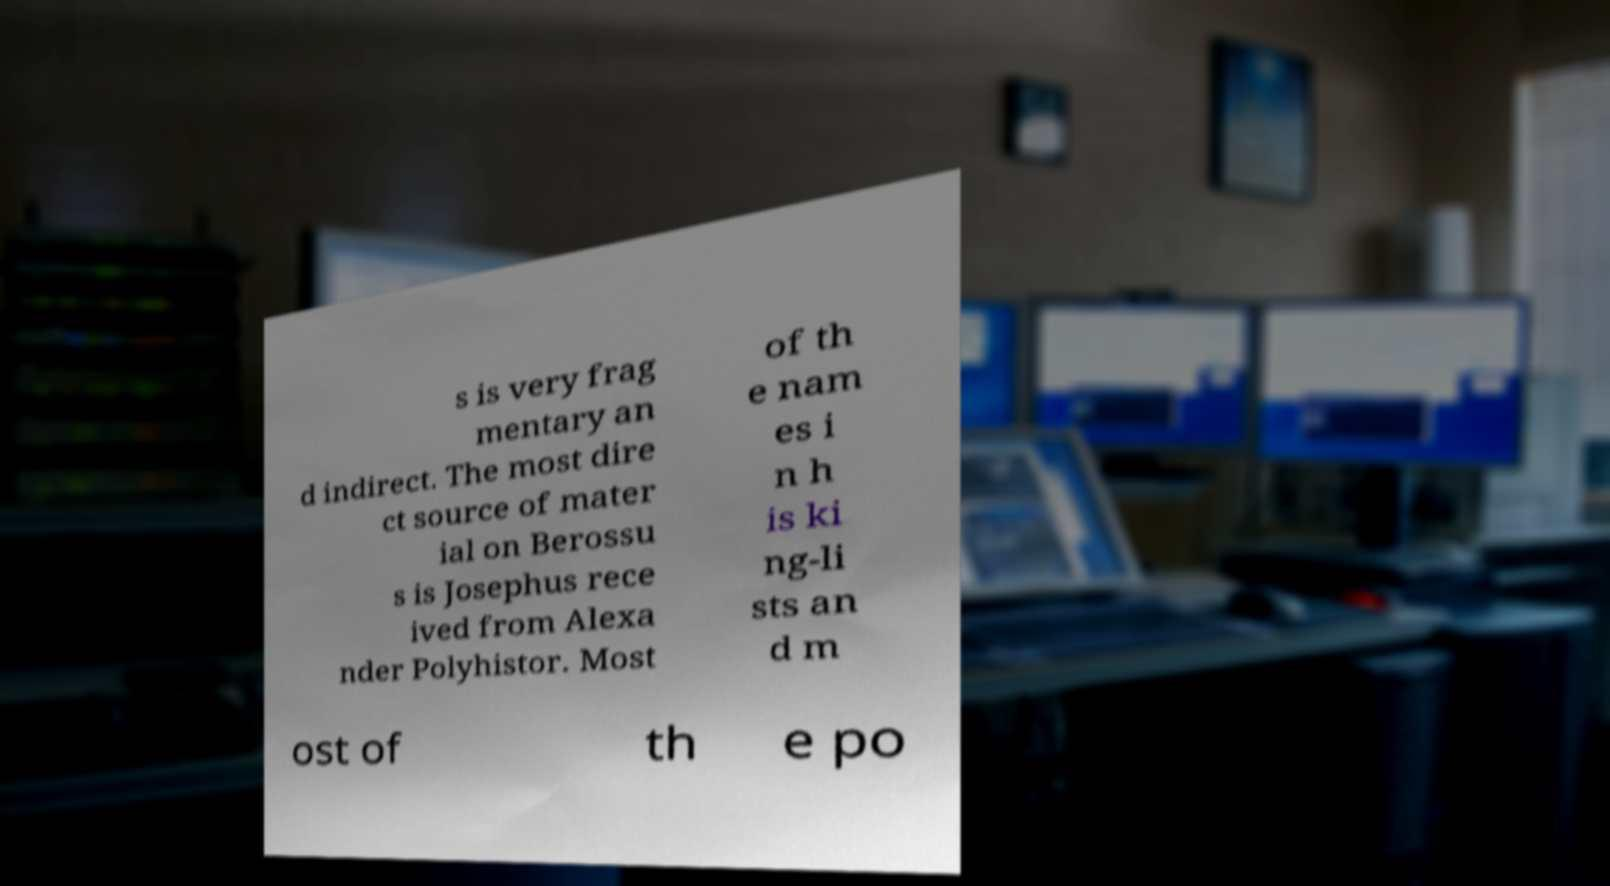What messages or text are displayed in this image? I need them in a readable, typed format. s is very frag mentary an d indirect. The most dire ct source of mater ial on Berossu s is Josephus rece ived from Alexa nder Polyhistor. Most of th e nam es i n h is ki ng-li sts an d m ost of th e po 